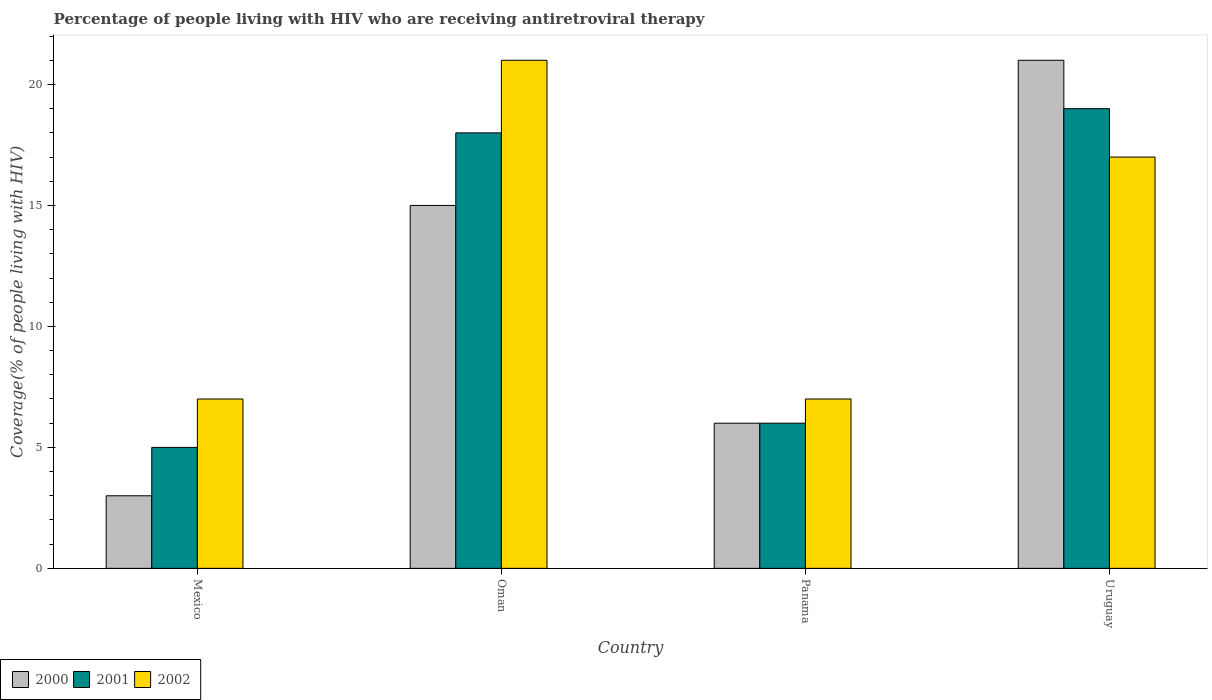How many different coloured bars are there?
Offer a terse response. 3. How many groups of bars are there?
Provide a succinct answer. 4. How many bars are there on the 4th tick from the left?
Your answer should be compact. 3. What is the percentage of the HIV infected people who are receiving antiretroviral therapy in 2002 in Panama?
Ensure brevity in your answer.  7. Across all countries, what is the maximum percentage of the HIV infected people who are receiving antiretroviral therapy in 2000?
Your answer should be very brief. 21. In which country was the percentage of the HIV infected people who are receiving antiretroviral therapy in 2000 maximum?
Ensure brevity in your answer.  Uruguay. What is the average percentage of the HIV infected people who are receiving antiretroviral therapy in 2000 per country?
Offer a terse response. 11.25. What is the ratio of the percentage of the HIV infected people who are receiving antiretroviral therapy in 2002 in Panama to that in Uruguay?
Your response must be concise. 0.41. What is the difference between the highest and the second highest percentage of the HIV infected people who are receiving antiretroviral therapy in 2000?
Keep it short and to the point. 15. What does the 3rd bar from the left in Panama represents?
Keep it short and to the point. 2002. Is it the case that in every country, the sum of the percentage of the HIV infected people who are receiving antiretroviral therapy in 2000 and percentage of the HIV infected people who are receiving antiretroviral therapy in 2001 is greater than the percentage of the HIV infected people who are receiving antiretroviral therapy in 2002?
Provide a succinct answer. Yes. How many bars are there?
Make the answer very short. 12. How many countries are there in the graph?
Keep it short and to the point. 4. Does the graph contain grids?
Make the answer very short. No. Where does the legend appear in the graph?
Your answer should be very brief. Bottom left. What is the title of the graph?
Keep it short and to the point. Percentage of people living with HIV who are receiving antiretroviral therapy. What is the label or title of the X-axis?
Make the answer very short. Country. What is the label or title of the Y-axis?
Offer a terse response. Coverage(% of people living with HIV). What is the Coverage(% of people living with HIV) in 2002 in Oman?
Offer a terse response. 21. What is the Coverage(% of people living with HIV) of 2000 in Panama?
Your answer should be compact. 6. What is the Coverage(% of people living with HIV) of 2002 in Panama?
Keep it short and to the point. 7. What is the Coverage(% of people living with HIV) of 2000 in Uruguay?
Your response must be concise. 21. What is the Coverage(% of people living with HIV) in 2001 in Uruguay?
Your response must be concise. 19. What is the Coverage(% of people living with HIV) of 2002 in Uruguay?
Offer a very short reply. 17. Across all countries, what is the maximum Coverage(% of people living with HIV) of 2000?
Ensure brevity in your answer.  21. What is the difference between the Coverage(% of people living with HIV) in 2000 in Mexico and that in Oman?
Your answer should be very brief. -12. What is the difference between the Coverage(% of people living with HIV) in 2000 in Mexico and that in Panama?
Offer a very short reply. -3. What is the difference between the Coverage(% of people living with HIV) in 2000 in Mexico and that in Uruguay?
Make the answer very short. -18. What is the difference between the Coverage(% of people living with HIV) in 2001 in Mexico and that in Uruguay?
Keep it short and to the point. -14. What is the difference between the Coverage(% of people living with HIV) of 2002 in Mexico and that in Uruguay?
Ensure brevity in your answer.  -10. What is the difference between the Coverage(% of people living with HIV) in 2000 in Oman and that in Panama?
Your answer should be very brief. 9. What is the difference between the Coverage(% of people living with HIV) in 2002 in Oman and that in Panama?
Give a very brief answer. 14. What is the difference between the Coverage(% of people living with HIV) in 2000 in Panama and that in Uruguay?
Your response must be concise. -15. What is the difference between the Coverage(% of people living with HIV) in 2002 in Panama and that in Uruguay?
Your answer should be compact. -10. What is the difference between the Coverage(% of people living with HIV) in 2000 in Mexico and the Coverage(% of people living with HIV) in 2002 in Panama?
Your answer should be very brief. -4. What is the difference between the Coverage(% of people living with HIV) in 2000 in Mexico and the Coverage(% of people living with HIV) in 2002 in Uruguay?
Your answer should be compact. -14. What is the difference between the Coverage(% of people living with HIV) in 2001 in Mexico and the Coverage(% of people living with HIV) in 2002 in Uruguay?
Make the answer very short. -12. What is the difference between the Coverage(% of people living with HIV) of 2000 in Oman and the Coverage(% of people living with HIV) of 2001 in Panama?
Offer a very short reply. 9. What is the difference between the Coverage(% of people living with HIV) in 2000 in Oman and the Coverage(% of people living with HIV) in 2002 in Panama?
Offer a very short reply. 8. What is the difference between the Coverage(% of people living with HIV) of 2000 in Oman and the Coverage(% of people living with HIV) of 2002 in Uruguay?
Your answer should be compact. -2. What is the difference between the Coverage(% of people living with HIV) in 2001 in Oman and the Coverage(% of people living with HIV) in 2002 in Uruguay?
Offer a very short reply. 1. What is the difference between the Coverage(% of people living with HIV) in 2000 in Panama and the Coverage(% of people living with HIV) in 2001 in Uruguay?
Your answer should be very brief. -13. What is the difference between the Coverage(% of people living with HIV) of 2000 in Panama and the Coverage(% of people living with HIV) of 2002 in Uruguay?
Your answer should be very brief. -11. What is the average Coverage(% of people living with HIV) of 2000 per country?
Make the answer very short. 11.25. What is the difference between the Coverage(% of people living with HIV) of 2000 and Coverage(% of people living with HIV) of 2001 in Mexico?
Offer a terse response. -2. What is the difference between the Coverage(% of people living with HIV) in 2000 and Coverage(% of people living with HIV) in 2002 in Mexico?
Your answer should be compact. -4. What is the difference between the Coverage(% of people living with HIV) of 2001 and Coverage(% of people living with HIV) of 2002 in Mexico?
Keep it short and to the point. -2. What is the difference between the Coverage(% of people living with HIV) of 2000 and Coverage(% of people living with HIV) of 2001 in Oman?
Your answer should be very brief. -3. What is the difference between the Coverage(% of people living with HIV) of 2001 and Coverage(% of people living with HIV) of 2002 in Oman?
Offer a very short reply. -3. What is the difference between the Coverage(% of people living with HIV) of 2000 and Coverage(% of people living with HIV) of 2002 in Panama?
Your answer should be compact. -1. What is the difference between the Coverage(% of people living with HIV) in 2001 and Coverage(% of people living with HIV) in 2002 in Panama?
Ensure brevity in your answer.  -1. What is the difference between the Coverage(% of people living with HIV) of 2000 and Coverage(% of people living with HIV) of 2001 in Uruguay?
Offer a terse response. 2. What is the ratio of the Coverage(% of people living with HIV) in 2000 in Mexico to that in Oman?
Offer a terse response. 0.2. What is the ratio of the Coverage(% of people living with HIV) in 2001 in Mexico to that in Oman?
Provide a short and direct response. 0.28. What is the ratio of the Coverage(% of people living with HIV) of 2000 in Mexico to that in Uruguay?
Offer a terse response. 0.14. What is the ratio of the Coverage(% of people living with HIV) in 2001 in Mexico to that in Uruguay?
Keep it short and to the point. 0.26. What is the ratio of the Coverage(% of people living with HIV) of 2002 in Mexico to that in Uruguay?
Provide a succinct answer. 0.41. What is the ratio of the Coverage(% of people living with HIV) in 2000 in Oman to that in Panama?
Offer a very short reply. 2.5. What is the ratio of the Coverage(% of people living with HIV) in 2001 in Oman to that in Panama?
Make the answer very short. 3. What is the ratio of the Coverage(% of people living with HIV) of 2000 in Oman to that in Uruguay?
Provide a short and direct response. 0.71. What is the ratio of the Coverage(% of people living with HIV) in 2002 in Oman to that in Uruguay?
Offer a very short reply. 1.24. What is the ratio of the Coverage(% of people living with HIV) in 2000 in Panama to that in Uruguay?
Give a very brief answer. 0.29. What is the ratio of the Coverage(% of people living with HIV) of 2001 in Panama to that in Uruguay?
Your response must be concise. 0.32. What is the ratio of the Coverage(% of people living with HIV) of 2002 in Panama to that in Uruguay?
Offer a very short reply. 0.41. What is the difference between the highest and the second highest Coverage(% of people living with HIV) in 2001?
Provide a short and direct response. 1. What is the difference between the highest and the second highest Coverage(% of people living with HIV) of 2002?
Keep it short and to the point. 4. What is the difference between the highest and the lowest Coverage(% of people living with HIV) of 2002?
Your answer should be very brief. 14. 